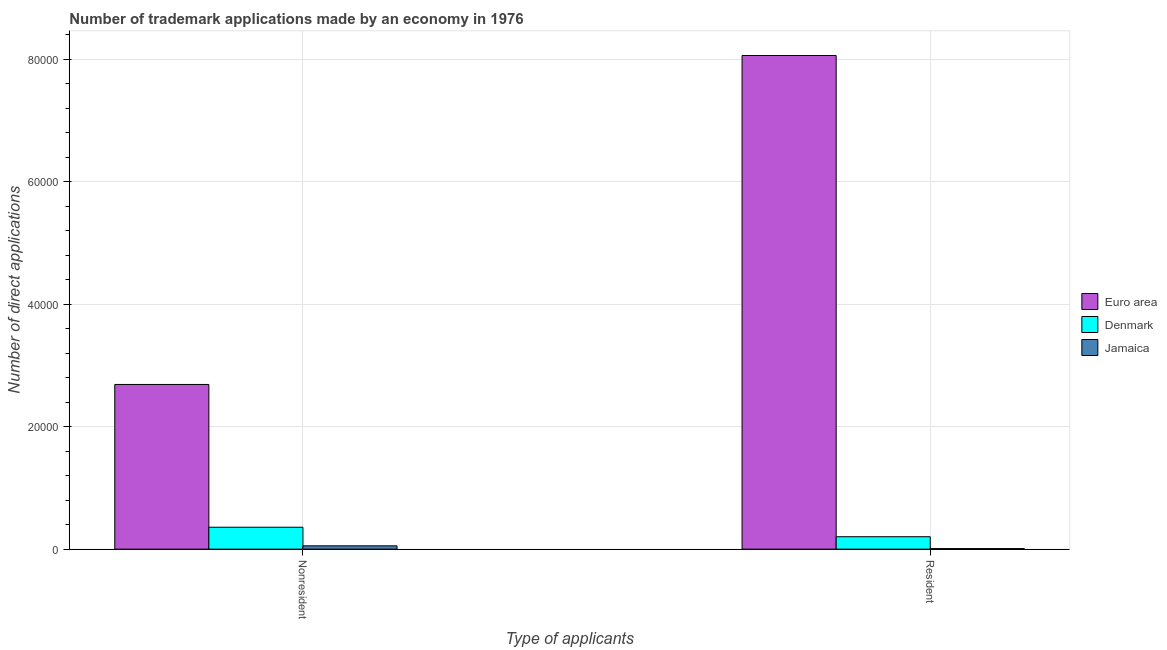Are the number of bars per tick equal to the number of legend labels?
Give a very brief answer. Yes. Are the number of bars on each tick of the X-axis equal?
Keep it short and to the point. Yes. What is the label of the 1st group of bars from the left?
Your answer should be compact. Nonresident. What is the number of trademark applications made by non residents in Jamaica?
Offer a very short reply. 541. Across all countries, what is the maximum number of trademark applications made by non residents?
Provide a succinct answer. 2.69e+04. Across all countries, what is the minimum number of trademark applications made by non residents?
Keep it short and to the point. 541. In which country was the number of trademark applications made by residents maximum?
Provide a succinct answer. Euro area. In which country was the number of trademark applications made by non residents minimum?
Keep it short and to the point. Jamaica. What is the total number of trademark applications made by residents in the graph?
Ensure brevity in your answer.  8.27e+04. What is the difference between the number of trademark applications made by residents in Denmark and that in Jamaica?
Offer a very short reply. 1940. What is the difference between the number of trademark applications made by residents in Euro area and the number of trademark applications made by non residents in Denmark?
Give a very brief answer. 7.70e+04. What is the average number of trademark applications made by residents per country?
Provide a short and direct response. 2.76e+04. What is the difference between the number of trademark applications made by non residents and number of trademark applications made by residents in Euro area?
Offer a very short reply. -5.37e+04. What is the ratio of the number of trademark applications made by non residents in Euro area to that in Jamaica?
Offer a terse response. 49.72. In how many countries, is the number of trademark applications made by non residents greater than the average number of trademark applications made by non residents taken over all countries?
Your response must be concise. 1. What does the 3rd bar from the right in Resident represents?
Ensure brevity in your answer.  Euro area. How many bars are there?
Make the answer very short. 6. Are all the bars in the graph horizontal?
Provide a succinct answer. No. What is the difference between two consecutive major ticks on the Y-axis?
Keep it short and to the point. 2.00e+04. Are the values on the major ticks of Y-axis written in scientific E-notation?
Provide a succinct answer. No. Does the graph contain any zero values?
Make the answer very short. No. Does the graph contain grids?
Your response must be concise. Yes. Where does the legend appear in the graph?
Offer a very short reply. Center right. How many legend labels are there?
Give a very brief answer. 3. What is the title of the graph?
Ensure brevity in your answer.  Number of trademark applications made by an economy in 1976. What is the label or title of the X-axis?
Make the answer very short. Type of applicants. What is the label or title of the Y-axis?
Your answer should be compact. Number of direct applications. What is the Number of direct applications in Euro area in Nonresident?
Ensure brevity in your answer.  2.69e+04. What is the Number of direct applications in Denmark in Nonresident?
Your answer should be compact. 3579. What is the Number of direct applications in Jamaica in Nonresident?
Your answer should be compact. 541. What is the Number of direct applications in Euro area in Resident?
Offer a terse response. 8.06e+04. What is the Number of direct applications of Denmark in Resident?
Ensure brevity in your answer.  2029. What is the Number of direct applications in Jamaica in Resident?
Make the answer very short. 89. Across all Type of applicants, what is the maximum Number of direct applications in Euro area?
Offer a terse response. 8.06e+04. Across all Type of applicants, what is the maximum Number of direct applications in Denmark?
Provide a short and direct response. 3579. Across all Type of applicants, what is the maximum Number of direct applications in Jamaica?
Offer a terse response. 541. Across all Type of applicants, what is the minimum Number of direct applications of Euro area?
Provide a short and direct response. 2.69e+04. Across all Type of applicants, what is the minimum Number of direct applications in Denmark?
Your answer should be very brief. 2029. Across all Type of applicants, what is the minimum Number of direct applications in Jamaica?
Keep it short and to the point. 89. What is the total Number of direct applications in Euro area in the graph?
Provide a succinct answer. 1.08e+05. What is the total Number of direct applications of Denmark in the graph?
Keep it short and to the point. 5608. What is the total Number of direct applications in Jamaica in the graph?
Keep it short and to the point. 630. What is the difference between the Number of direct applications in Euro area in Nonresident and that in Resident?
Your answer should be very brief. -5.37e+04. What is the difference between the Number of direct applications in Denmark in Nonresident and that in Resident?
Your answer should be compact. 1550. What is the difference between the Number of direct applications of Jamaica in Nonresident and that in Resident?
Give a very brief answer. 452. What is the difference between the Number of direct applications of Euro area in Nonresident and the Number of direct applications of Denmark in Resident?
Ensure brevity in your answer.  2.49e+04. What is the difference between the Number of direct applications of Euro area in Nonresident and the Number of direct applications of Jamaica in Resident?
Your answer should be very brief. 2.68e+04. What is the difference between the Number of direct applications of Denmark in Nonresident and the Number of direct applications of Jamaica in Resident?
Your answer should be very brief. 3490. What is the average Number of direct applications of Euro area per Type of applicants?
Your answer should be compact. 5.38e+04. What is the average Number of direct applications of Denmark per Type of applicants?
Provide a short and direct response. 2804. What is the average Number of direct applications in Jamaica per Type of applicants?
Your answer should be compact. 315. What is the difference between the Number of direct applications in Euro area and Number of direct applications in Denmark in Nonresident?
Keep it short and to the point. 2.33e+04. What is the difference between the Number of direct applications of Euro area and Number of direct applications of Jamaica in Nonresident?
Your answer should be very brief. 2.64e+04. What is the difference between the Number of direct applications in Denmark and Number of direct applications in Jamaica in Nonresident?
Give a very brief answer. 3038. What is the difference between the Number of direct applications in Euro area and Number of direct applications in Denmark in Resident?
Your answer should be compact. 7.86e+04. What is the difference between the Number of direct applications of Euro area and Number of direct applications of Jamaica in Resident?
Give a very brief answer. 8.05e+04. What is the difference between the Number of direct applications in Denmark and Number of direct applications in Jamaica in Resident?
Offer a very short reply. 1940. What is the ratio of the Number of direct applications of Euro area in Nonresident to that in Resident?
Your answer should be very brief. 0.33. What is the ratio of the Number of direct applications of Denmark in Nonresident to that in Resident?
Provide a short and direct response. 1.76. What is the ratio of the Number of direct applications in Jamaica in Nonresident to that in Resident?
Give a very brief answer. 6.08. What is the difference between the highest and the second highest Number of direct applications of Euro area?
Your answer should be very brief. 5.37e+04. What is the difference between the highest and the second highest Number of direct applications of Denmark?
Provide a succinct answer. 1550. What is the difference between the highest and the second highest Number of direct applications in Jamaica?
Offer a terse response. 452. What is the difference between the highest and the lowest Number of direct applications of Euro area?
Provide a short and direct response. 5.37e+04. What is the difference between the highest and the lowest Number of direct applications in Denmark?
Your answer should be compact. 1550. What is the difference between the highest and the lowest Number of direct applications in Jamaica?
Provide a succinct answer. 452. 